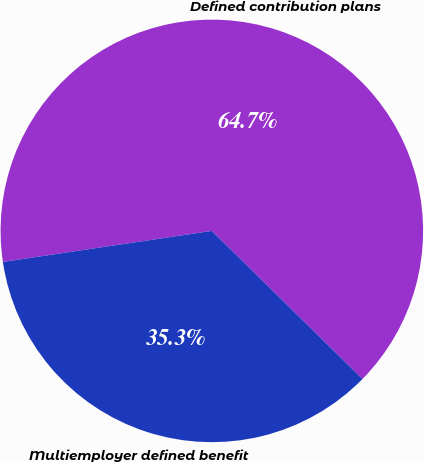Convert chart. <chart><loc_0><loc_0><loc_500><loc_500><pie_chart><fcel>Defined contribution plans<fcel>Multiemployer defined benefit<nl><fcel>64.71%<fcel>35.29%<nl></chart> 